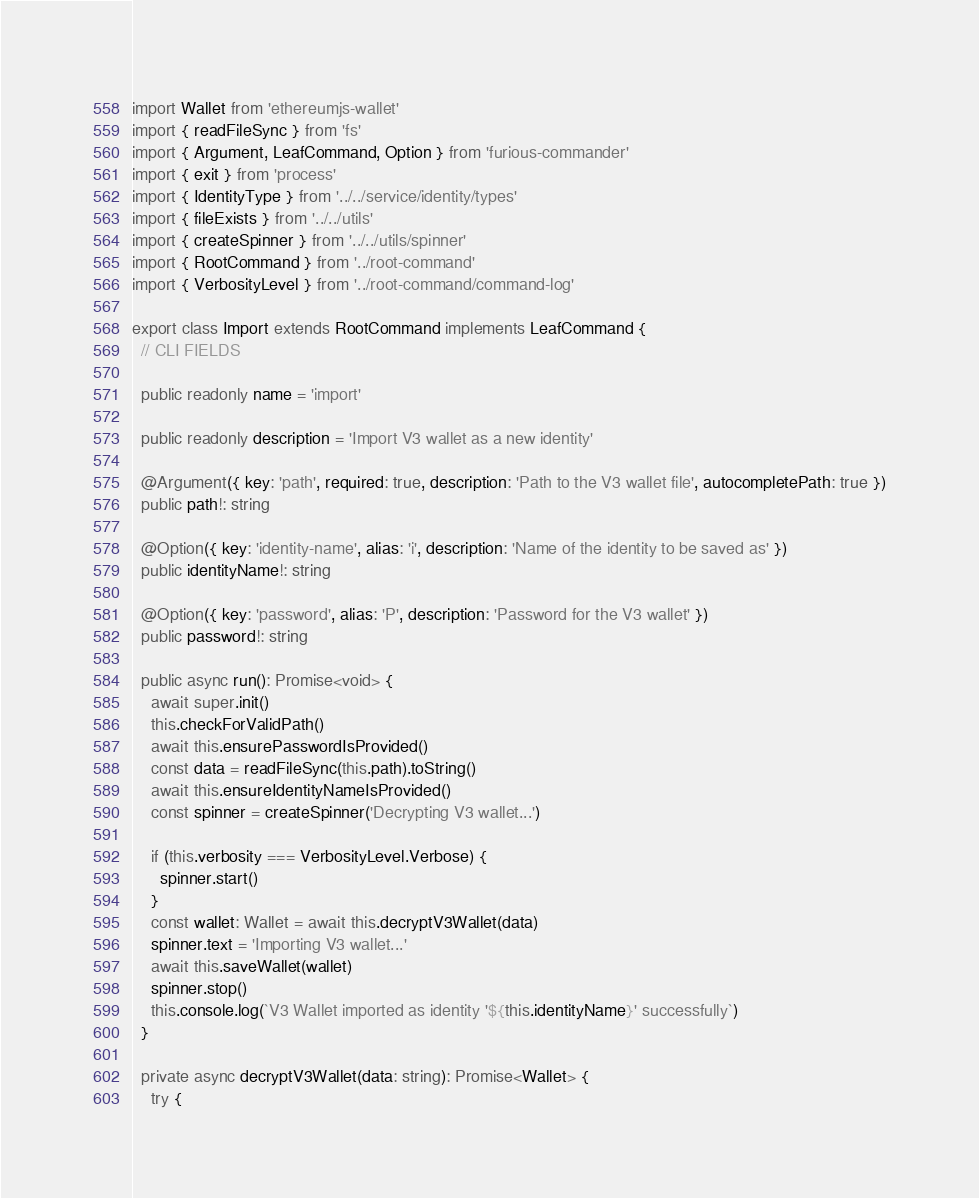Convert code to text. <code><loc_0><loc_0><loc_500><loc_500><_TypeScript_>import Wallet from 'ethereumjs-wallet'
import { readFileSync } from 'fs'
import { Argument, LeafCommand, Option } from 'furious-commander'
import { exit } from 'process'
import { IdentityType } from '../../service/identity/types'
import { fileExists } from '../../utils'
import { createSpinner } from '../../utils/spinner'
import { RootCommand } from '../root-command'
import { VerbosityLevel } from '../root-command/command-log'

export class Import extends RootCommand implements LeafCommand {
  // CLI FIELDS

  public readonly name = 'import'

  public readonly description = 'Import V3 wallet as a new identity'

  @Argument({ key: 'path', required: true, description: 'Path to the V3 wallet file', autocompletePath: true })
  public path!: string

  @Option({ key: 'identity-name', alias: 'i', description: 'Name of the identity to be saved as' })
  public identityName!: string

  @Option({ key: 'password', alias: 'P', description: 'Password for the V3 wallet' })
  public password!: string

  public async run(): Promise<void> {
    await super.init()
    this.checkForValidPath()
    await this.ensurePasswordIsProvided()
    const data = readFileSync(this.path).toString()
    await this.ensureIdentityNameIsProvided()
    const spinner = createSpinner('Decrypting V3 wallet...')

    if (this.verbosity === VerbosityLevel.Verbose) {
      spinner.start()
    }
    const wallet: Wallet = await this.decryptV3Wallet(data)
    spinner.text = 'Importing V3 wallet...'
    await this.saveWallet(wallet)
    spinner.stop()
    this.console.log(`V3 Wallet imported as identity '${this.identityName}' successfully`)
  }

  private async decryptV3Wallet(data: string): Promise<Wallet> {
    try {</code> 